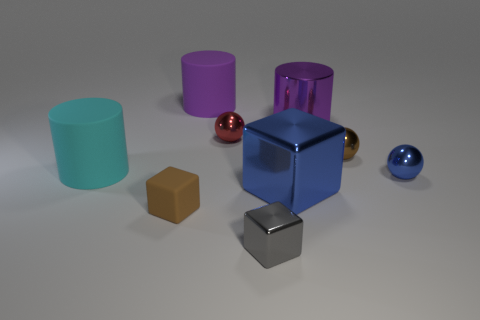There is a rubber cylinder that is the same color as the metal cylinder; what size is it?
Provide a succinct answer. Large. There is a object that is the same color as the large shiny block; what is its material?
Give a very brief answer. Metal. Is the number of things in front of the big blue metal thing less than the number of big blue blocks that are on the right side of the small blue object?
Make the answer very short. No. Do the cyan rubber object and the large blue object have the same shape?
Ensure brevity in your answer.  No. How many other objects are the same size as the gray metal thing?
Offer a very short reply. 4. How many objects are either small shiny things that are to the left of the small blue shiny object or metallic spheres right of the big shiny block?
Ensure brevity in your answer.  4. What number of purple objects are the same shape as the cyan object?
Provide a succinct answer. 2. There is a tiny ball that is to the right of the red shiny thing and behind the large cyan matte cylinder; what material is it made of?
Ensure brevity in your answer.  Metal. How many brown rubber blocks are right of the red sphere?
Ensure brevity in your answer.  0. What number of brown metallic balls are there?
Ensure brevity in your answer.  1. 